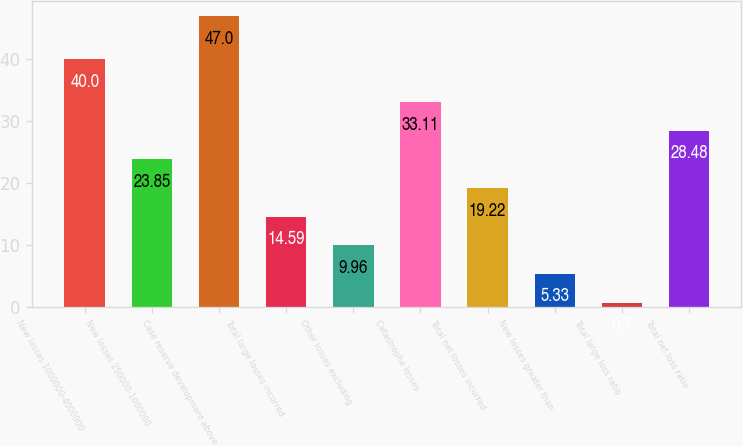Convert chart to OTSL. <chart><loc_0><loc_0><loc_500><loc_500><bar_chart><fcel>New losses 1000000-4000000<fcel>New losses 250000-1000000<fcel>Case reserve development above<fcel>Total large losses incurred<fcel>Other losses excluding<fcel>Catastrophe losses<fcel>Total net losses incurred<fcel>New losses greater than<fcel>Total large loss ratio<fcel>Total net loss ratio<nl><fcel>40<fcel>23.85<fcel>47<fcel>14.59<fcel>9.96<fcel>33.11<fcel>19.22<fcel>5.33<fcel>0.7<fcel>28.48<nl></chart> 